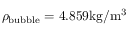<formula> <loc_0><loc_0><loc_500><loc_500>\rho _ { b u b b l e } = 4 . 8 5 9 { k g / m ^ { 3 } }</formula> 